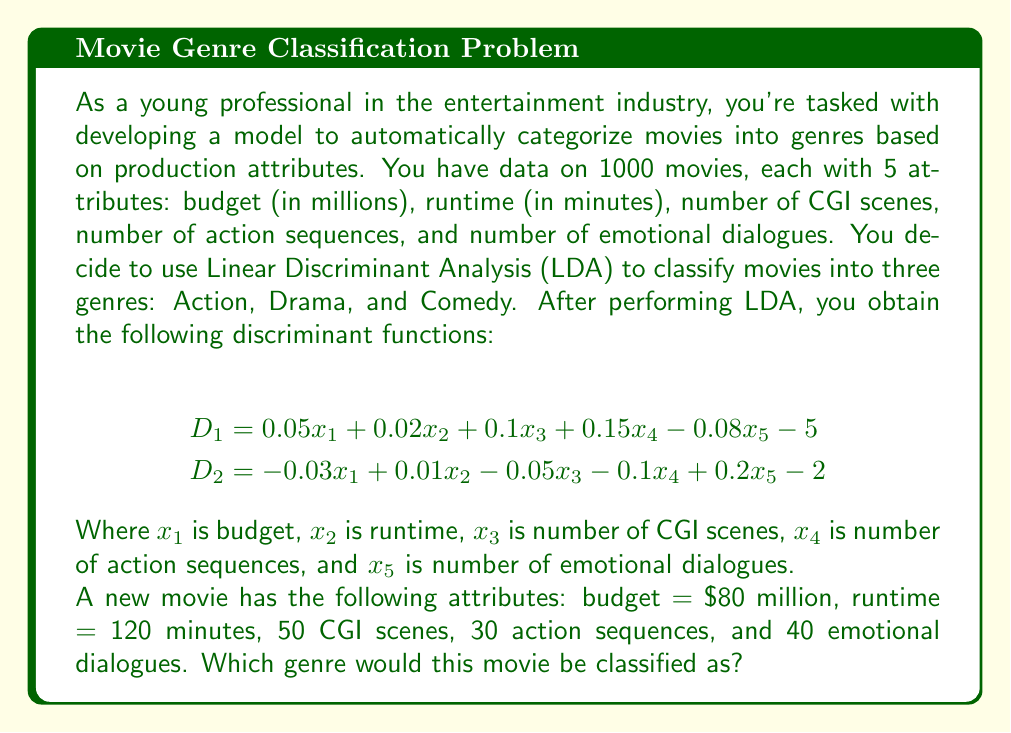Give your solution to this math problem. To solve this problem, we need to follow these steps:

1. Calculate the values of $D_1$ and $D_2$ using the given discriminant functions and the new movie's attributes.

2. Use the decision rule for three-group LDA: 
   - If $D_1 > 0$ and $D_2 > 0$, classify as Action
   - If $D_1 < 0$ and $D_2 > D_1$, classify as Drama
   - If $D_2 < 0$ and $D_1 > D_2$, classify as Comedy

Let's calculate $D_1$ and $D_2$:

For $D_1$:
$$\begin{align}
D_1 &= 0.05x_1 + 0.02x_2 + 0.1x_3 + 0.15x_4 - 0.08x_5 - 5 \\
&= 0.05(80) + 0.02(120) + 0.1(50) + 0.15(30) - 0.08(40) - 5 \\
&= 4 + 2.4 + 5 + 4.5 - 3.2 - 5 \\
&= 7.7
\end{align}$$

For $D_2$:
$$\begin{align}
D_2 &= -0.03x_1 + 0.01x_2 - 0.05x_3 - 0.1x_4 + 0.2x_5 - 2 \\
&= -0.03(80) + 0.01(120) - 0.05(50) - 0.1(30) + 0.2(40) - 2 \\
&= -2.4 + 1.2 - 2.5 - 3 + 8 - 2 \\
&= -0.7
\end{align}$$

Now, we can apply the decision rule:
$D_1 = 7.7 > 0$ and $D_2 = -0.7 < 0$

Since $D_1 > 0$ and $D_2 < 0$, and $D_1 > D_2$, this movie would be classified as Comedy.
Answer: Comedy 